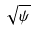<formula> <loc_0><loc_0><loc_500><loc_500>\sqrt { \psi }</formula> 